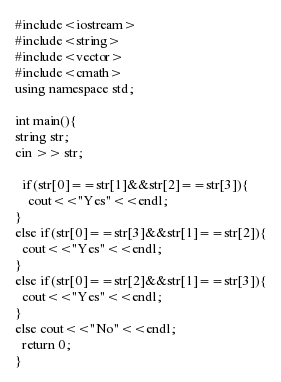<code> <loc_0><loc_0><loc_500><loc_500><_C++_>#include<iostream>
#include<string>
#include<vector>
#include<cmath>
using namespace std;

int main(){
string str;
cin >> str;

  if(str[0]==str[1]&&str[2]==str[3]){
    cout<<"Yes"<<endl;
}
else if(str[0]==str[3]&&str[1]==str[2]){
  cout<<"Yes"<<endl;
}
else if(str[0]==str[2]&&str[1]==str[3]){
  cout<<"Yes"<<endl;
}
else cout<<"No"<<endl;
  return 0;
}
</code> 